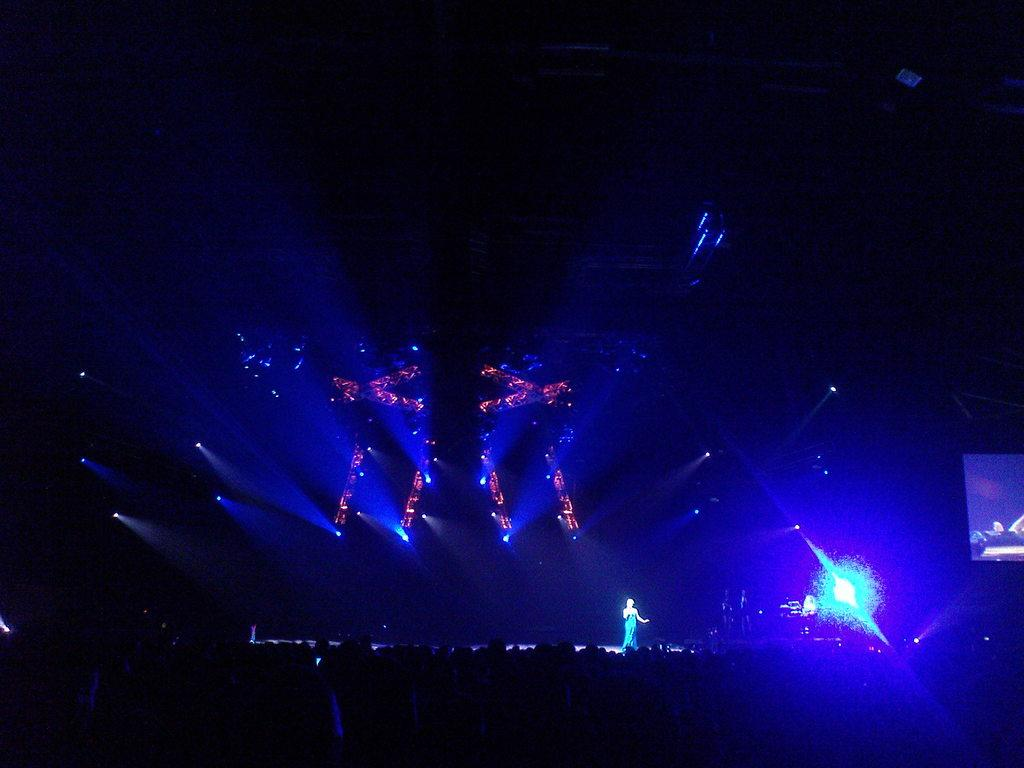What is the woman in the image doing? The woman is standing on the stage in the image. What is the woman wearing? The woman is wearing a blue dress. What can be seen on the stage besides the woman? Stage lights and a screen are present on the stage. How would you describe the lighting in the image? The image appears to be slightly dark. What type of metal is the woman offering to the audience in the image? There is no metal being offered to the audience in the image; the woman is simply standing on the stage. 